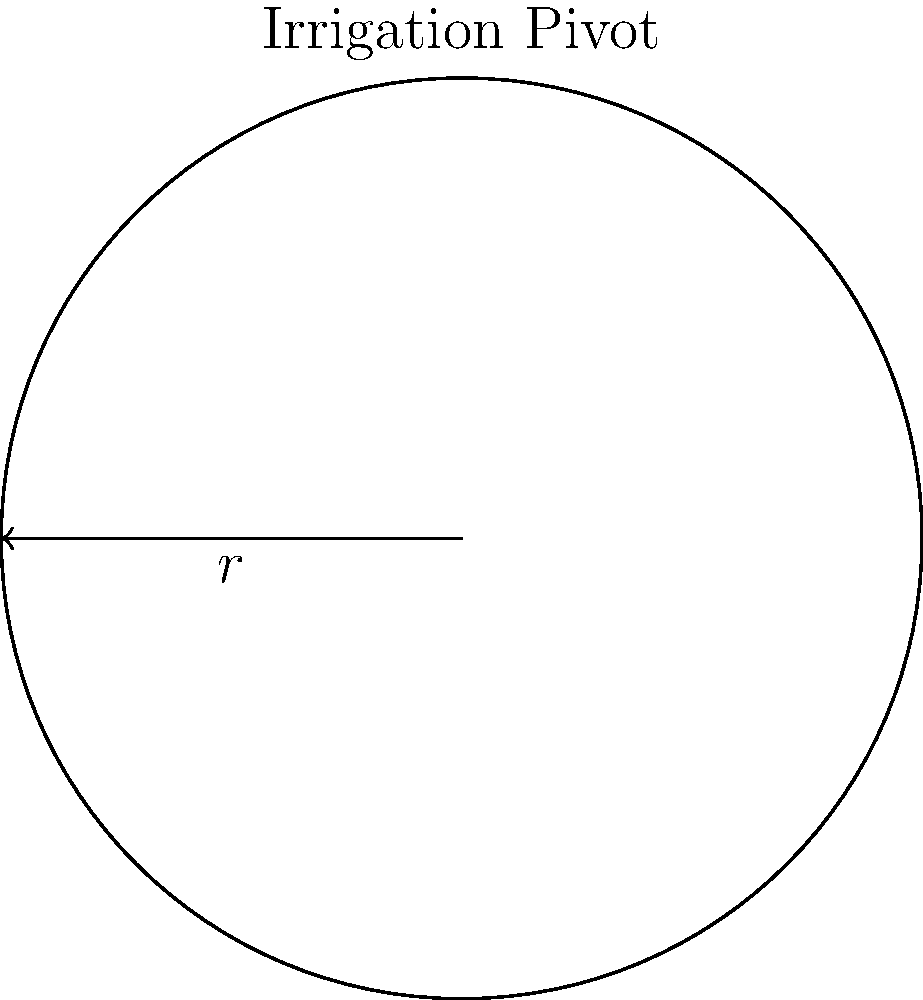A circular irrigation pivot system has a radius of 400 meters. Estimate the perimeter of the area covered by this system, assuming it makes a complete rotation. How might this information be useful in assessing water distribution efficiency and potential climate change impacts on irrigation? To solve this problem, we'll follow these steps:

1) Recall the formula for the circumference (perimeter) of a circle:
   $$ C = 2\pi r $$
   where $C$ is the circumference, $\pi$ is pi, and $r$ is the radius.

2) We're given that the radius $r = 400$ meters.

3) Substitute the values into the formula:
   $$ C = 2\pi (400) $$

4) $\pi$ is approximately 3.14159, but for estimation, we can use 3.14:
   $$ C \approx 2(3.14)(400) = 2512 \text{ meters} $$

5) Therefore, the estimated perimeter of the irrigation system is about 2512 meters.

This information is useful for assessing water distribution efficiency and potential climate change impacts on irrigation in several ways:

a) Water usage calculation: Knowing the perimeter helps estimate the total area irrigated, which is crucial for calculating water requirements and usage.

b) Energy consumption: The size of the system affects the energy needed to pump water, an important factor in irrigation economics and carbon footprint assessment.

c) Evaporation losses: A larger perimeter means more exposure to air, potentially increasing evaporation. This is particularly relevant in the context of rising temperatures due to climate change.

d) Adaptation strategies: Understanding the scale of current systems helps in planning adaptations to changing climate conditions, such as switching to more water-efficient crops or irrigation methods.

e) Economic analysis: The size of the system is a key factor in cost-benefit analyses of irrigation investments, especially important when considering climate change scenarios.
Answer: 2512 meters 